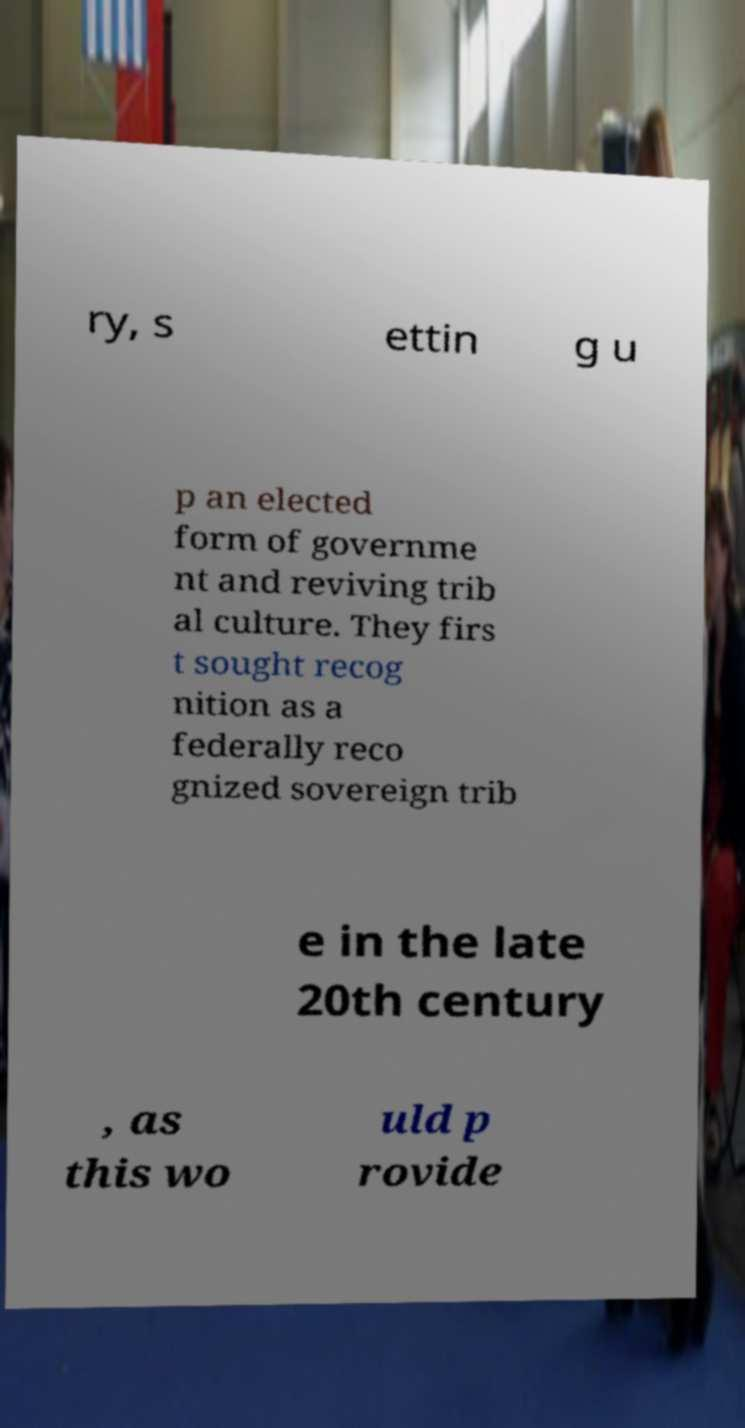What messages or text are displayed in this image? I need them in a readable, typed format. ry, s ettin g u p an elected form of governme nt and reviving trib al culture. They firs t sought recog nition as a federally reco gnized sovereign trib e in the late 20th century , as this wo uld p rovide 